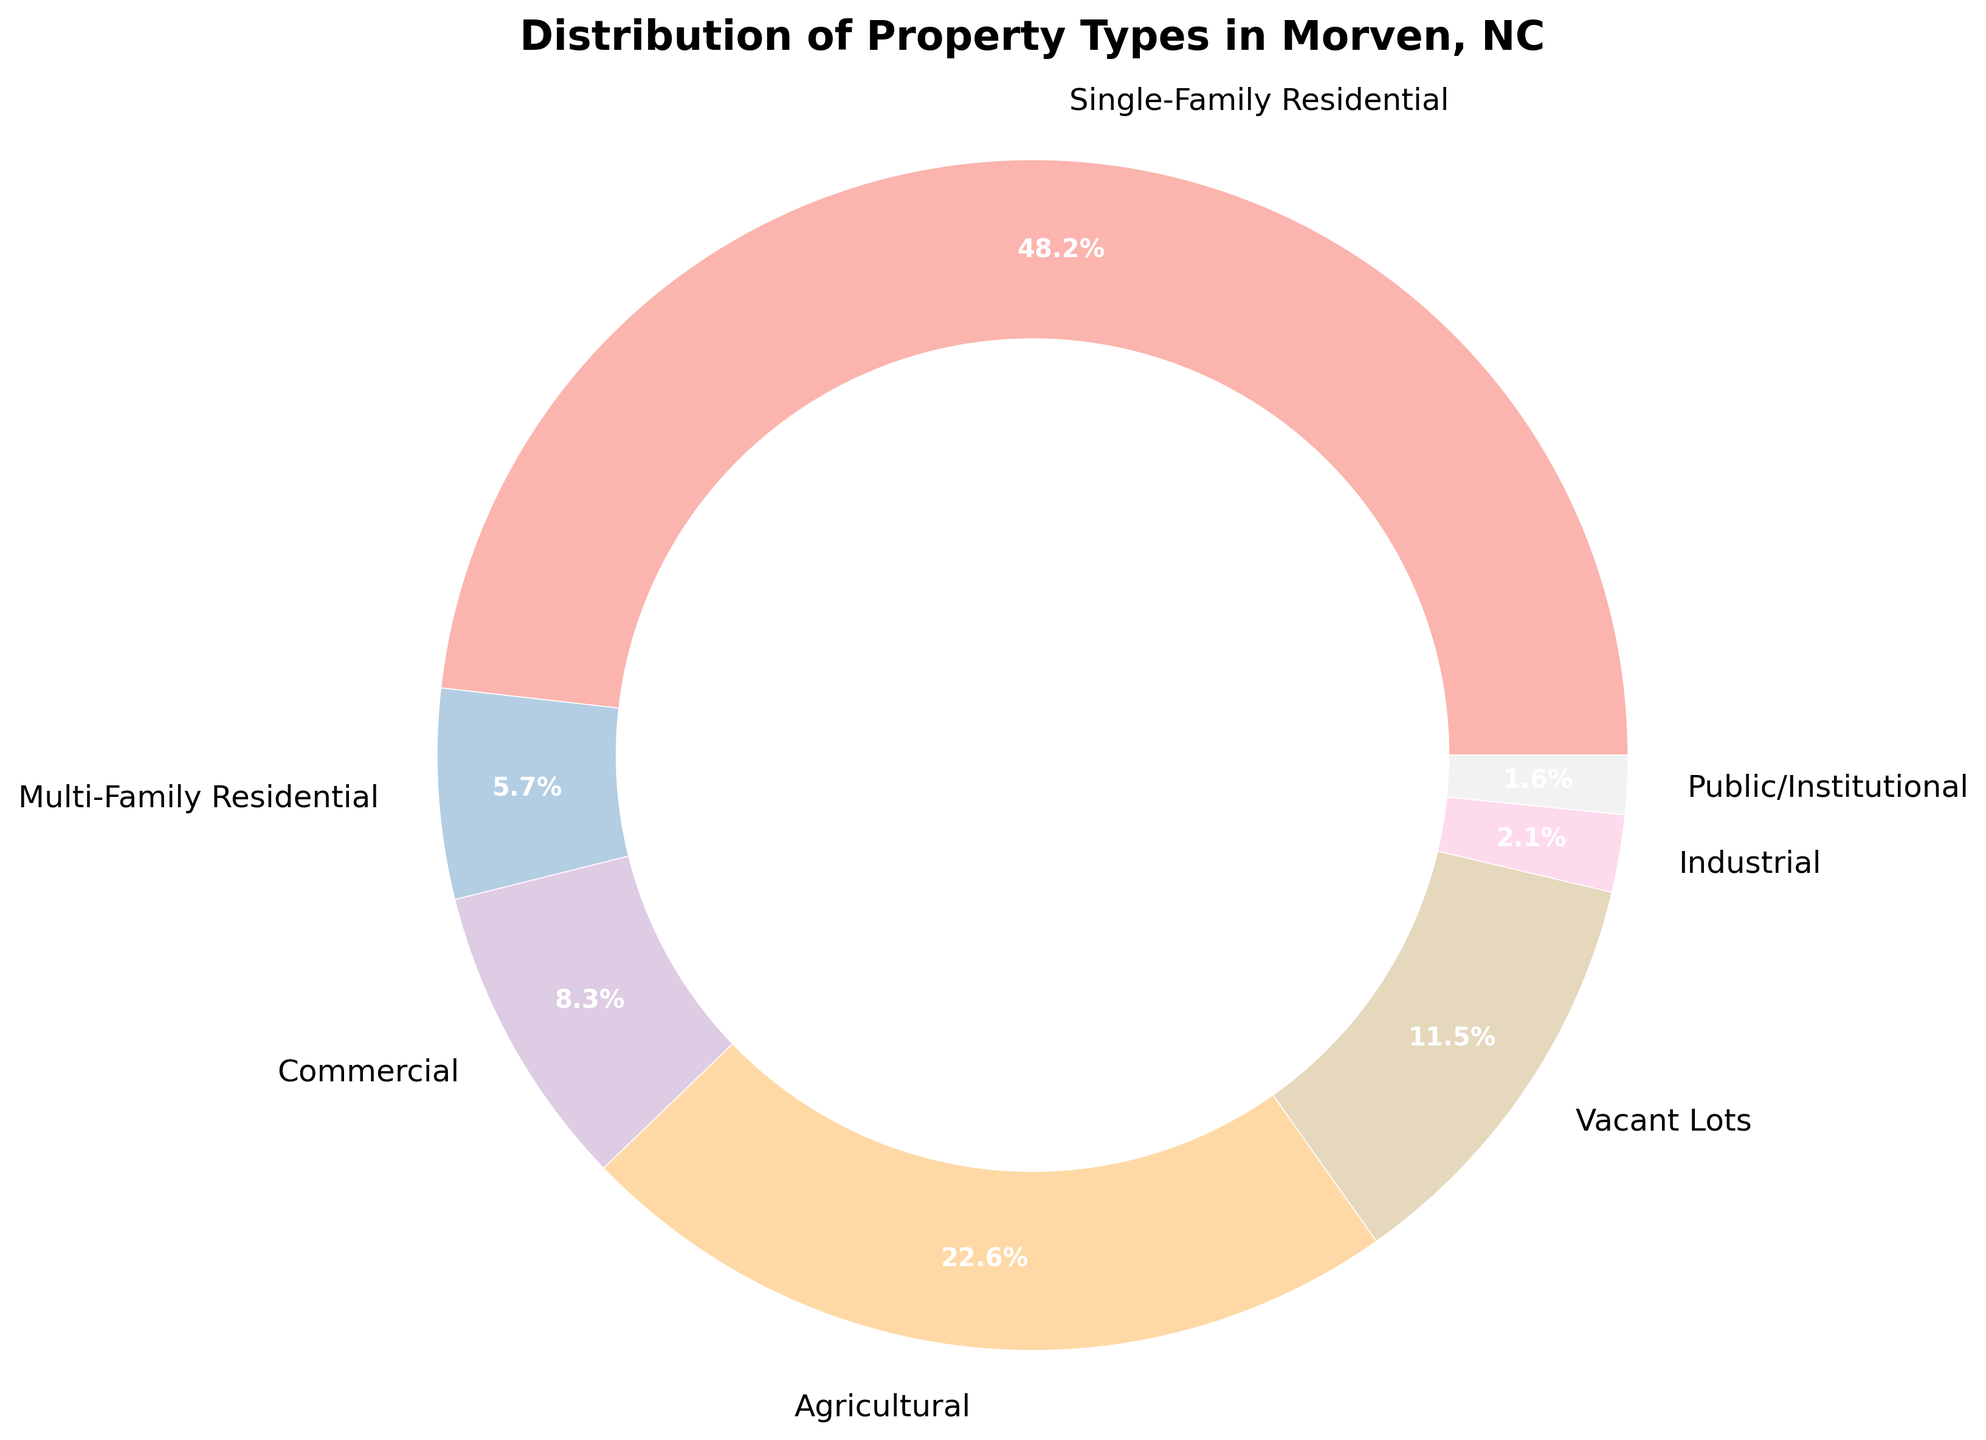What percentage of properties in Morven, NC are either Agricultural or Vacant Lots? To find the percentage of properties that are either Agricultural or Vacant Lots, sum the percentages of Agricultural properties (22.6%) and Vacant Lots (11.5%). The sum is 22.6 + 11.5 = 34.1%.
Answer: 34.1% Which property type has the smallest percentage in Morven, NC? By examining the pie chart, the smallest percentage slice corresponds to the Public/Institutional property type, which is 1.6%.
Answer: Public/Institutional Are there more Single-Family Residential properties or Commercial properties in Morven, NC? Comparing the percentages of Single-Family Residential (48.2%) and Commercial properties (8.3%), Single-Family Residential properties have a higher percentage.
Answer: Single-Family Residential What is the combined percentage of Single-Family Residential and Multi-Family Residential properties? To find the combined percentage, sum the percentages of Single-Family Residential (48.2%) and Multi-Family Residential (5.7%). The total is 48.2 + 5.7 = 53.9%.
Answer: 53.9% Which color represents Agricultural properties in the pie chart? Identify the color of the wedge labeled Agricultural on the pie chart. The specific color can't be described without the actual visual, but it is one of the colors in the Pastel1 color scheme used in the chart.
Answer: Pastel1 scheme color What is the difference in percentage between Industrial and Public/Institutional properties? Subtract the percentage of Public/Institutional properties (1.6%) from the Industrial properties percentage (2.1%). The difference is 2.1 - 1.6 = 0.5%.
Answer: 0.5% Do Residential properties (Single-Family and Multi-Family combined) form a majority of the properties in Morven, NC? Combine the percentages of Single-Family Residential (48.2%) and Multi-Family Residential (5.7%), which is 48.2 + 5.7 = 53.9%. Since this exceeds 50%, they form a majority.
Answer: Yes How much more common are Single-Family Residential properties compared to Multi-Family Residential properties? Subtract the percentage of Multi-Family Residential (5.7%) from Single-Family Residential properties (48.2%). The difference is 48.2 - 5.7 = 42.5%.
Answer: 42.5% If you wanted to invest in the most common property type, which would you choose based on the chart? The most common property type in the pie chart is Single-Family Residential, which has the highest percentage at 48.2%.
Answer: Single-Family Residential What is the average percentage of Commercial and Industrial properties? First, find the sum of the percentages of Commercial (8.3%) and Industrial (2.1%) properties, which is 8.3 + 2.1 = 10.4%. Then, divide by 2 to get the average. The average is 10.4 / 2 = 5.2%.
Answer: 5.2% 